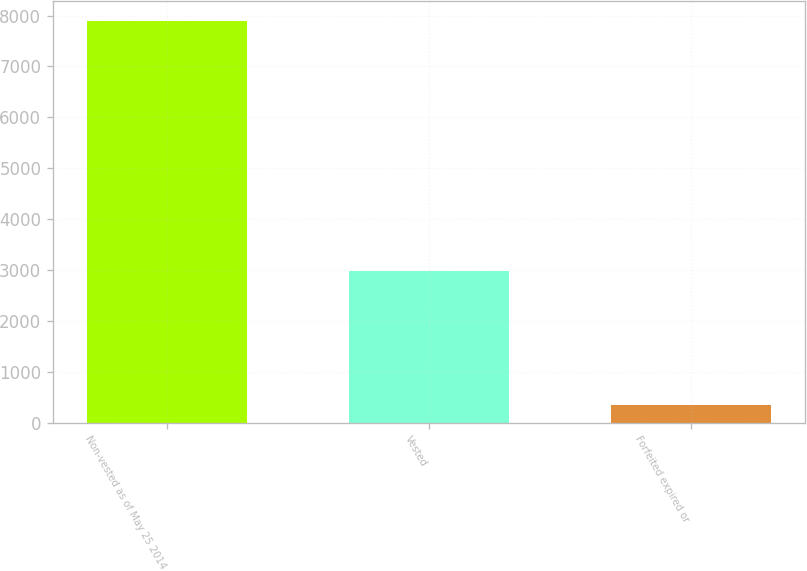<chart> <loc_0><loc_0><loc_500><loc_500><bar_chart><fcel>Non-vested as of May 25 2014<fcel>Vested<fcel>Forfeited expired or<nl><fcel>7893.7<fcel>2978.7<fcel>338.1<nl></chart> 